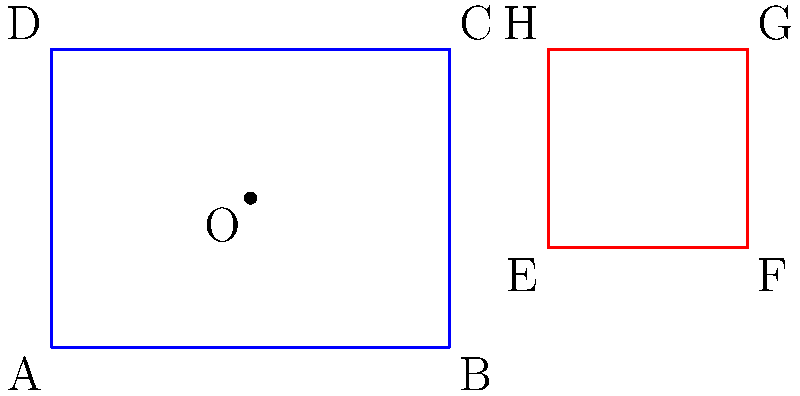As a university dean exploring cost-effective solutions for software licenses, you're analyzing a geometric problem that could potentially optimize resource allocation. Consider the blue rectangle ABCD and the red fixed shape EFGH in the diagram. The point O is the center of rotation for the blue rectangle. What is the minimum angle of rotation (in degrees) needed to minimize the overlap between the blue rectangle and the red fixed shape? To solve this problem, we'll follow these steps:

1. Observe that the blue rectangle needs to be rotated counterclockwise to minimize overlap.

2. The critical point of rotation is when vertex C of the blue rectangle aligns with edge EF of the red shape.

3. To find the angle of rotation, we need to calculate:
   a) The angle between OC and the positive x-axis
   b) The angle between OE and the positive x-axis

4. Calculate angle COB:
   $\tan(COB) = \frac{1.5}{2} = 0.75$
   $COB = \arctan(0.75) \approx 36.87°$

5. Calculate angle OCB:
   $\tan(OCB) = \frac{2}{1.5} = \frac{4}{3}$
   $OCB = \arctan(\frac{4}{3}) \approx 53.13°$

6. The angle between OC and the positive x-axis:
   $90° - 36.87° = 53.13°$

7. Calculate angle OEB:
   $\tan(OEB) = \frac{0.5}{3} = \frac{1}{6}$
   $OEB = \arctan(\frac{1}{6}) \approx 9.46°$

8. The minimum angle of rotation is the difference between these angles:
   $53.13° - 9.46° = 43.67°$

9. Round to the nearest degree: 44°
Answer: 44° 